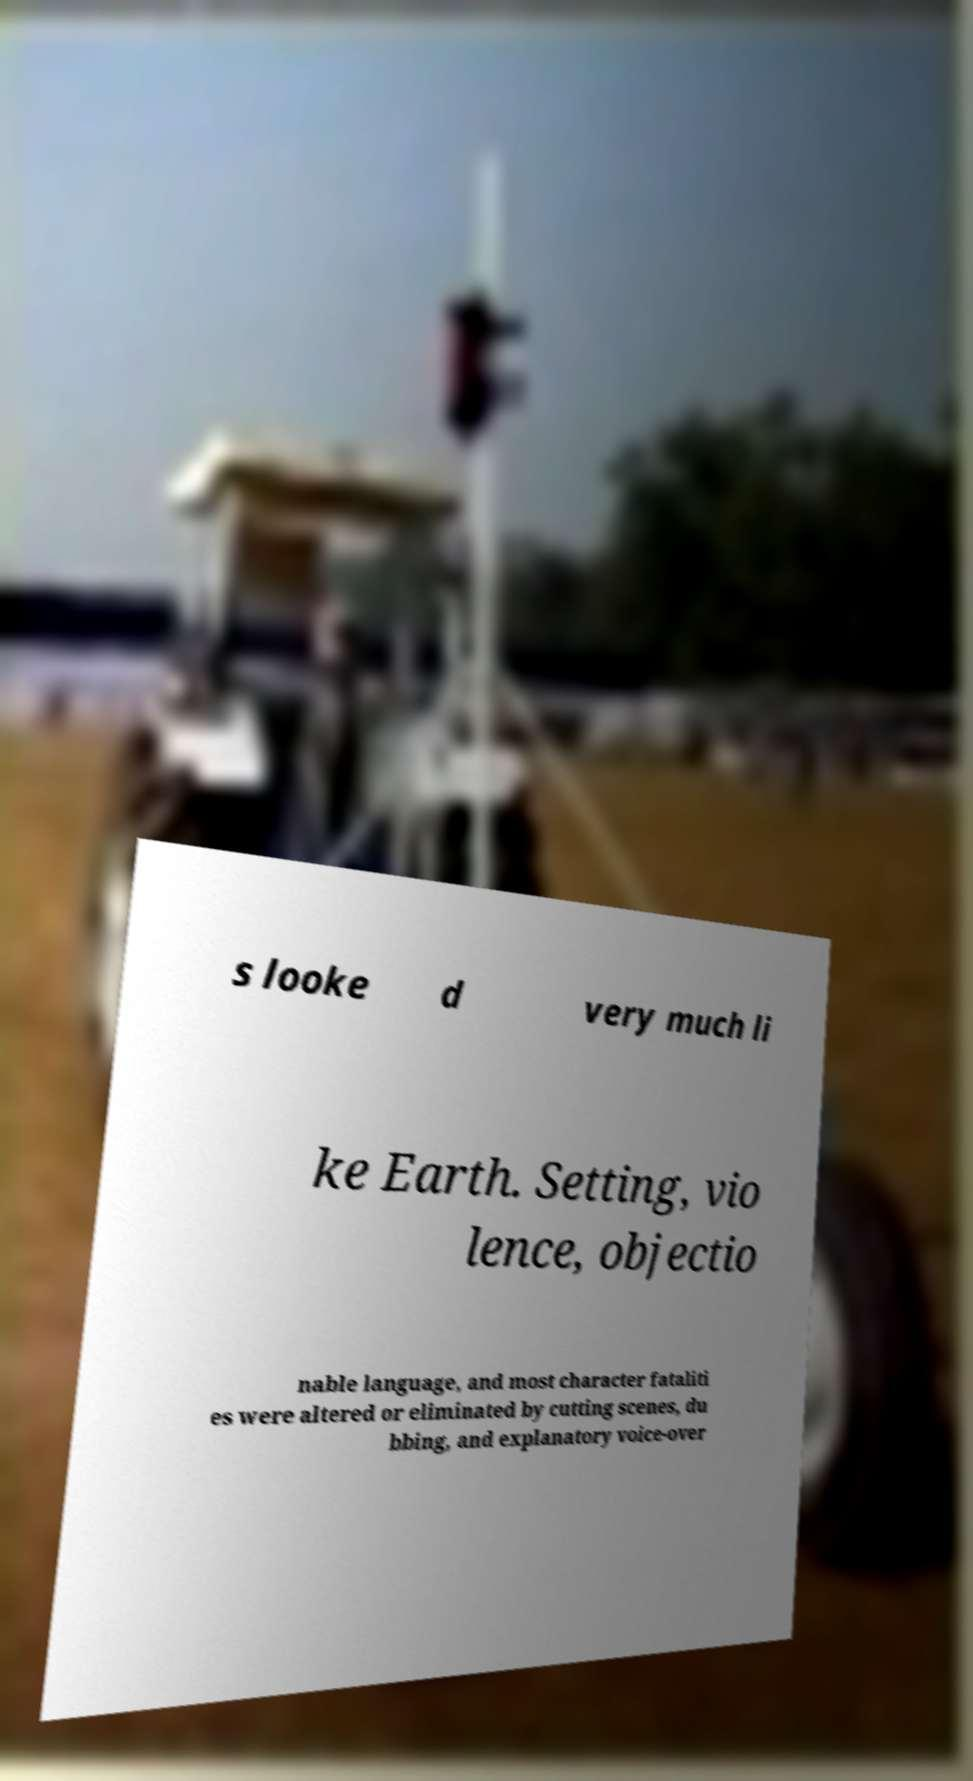Can you accurately transcribe the text from the provided image for me? s looke d very much li ke Earth. Setting, vio lence, objectio nable language, and most character fataliti es were altered or eliminated by cutting scenes, du bbing, and explanatory voice-over 